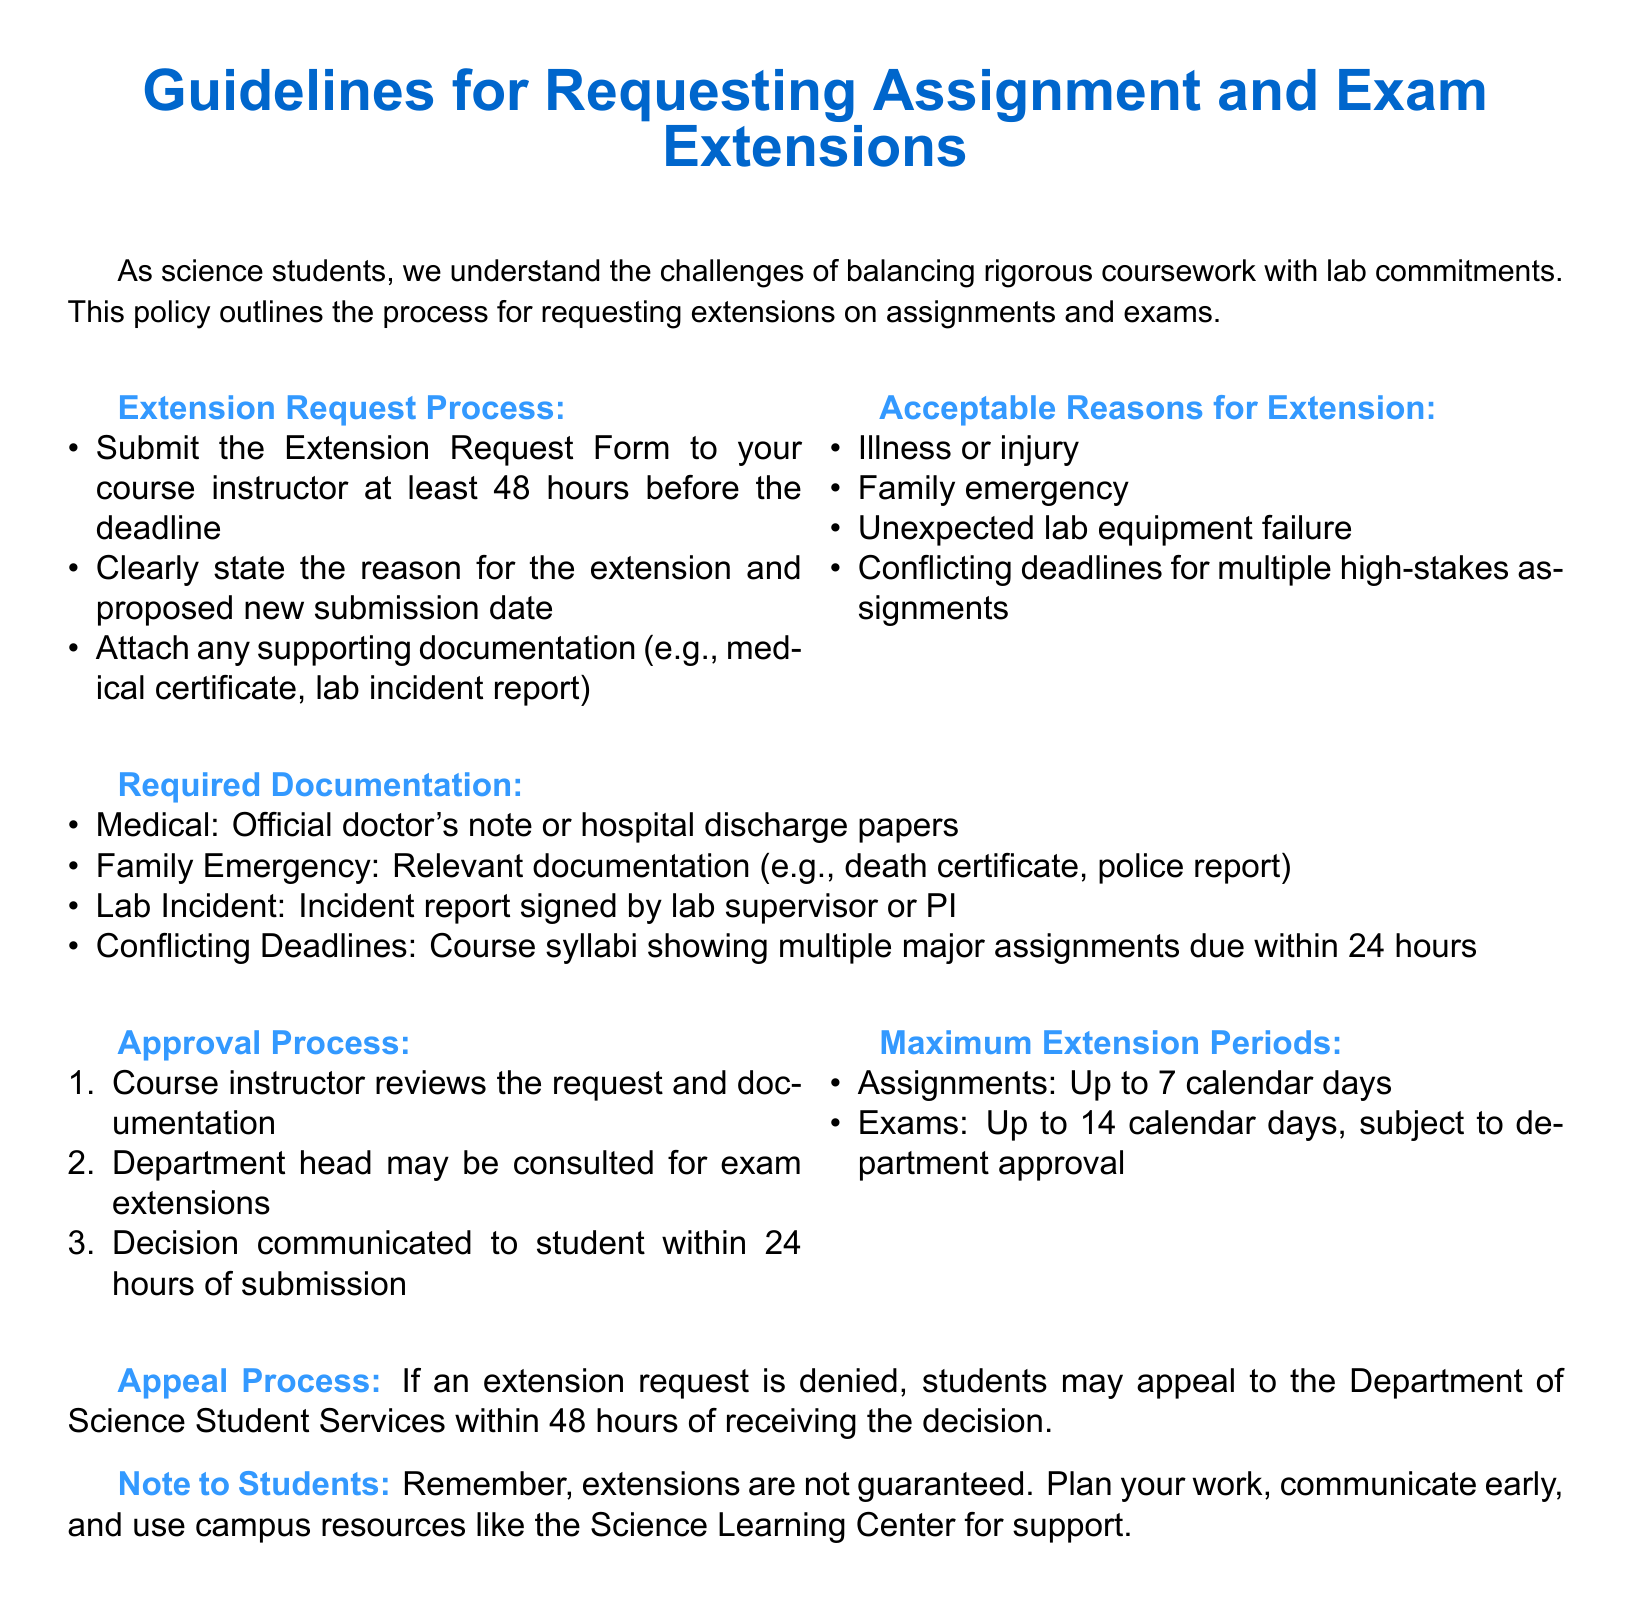What is the maximum extension period for assignments? The document states that the maximum extension period for assignments is seven calendar days.
Answer: 7 calendar days What is the required documentation for a medical condition? The document specifies that an official doctor's note or hospital discharge papers are required for medical conditions.
Answer: Official doctor's note How long before a deadline should you submit an extension request? According to the guidelines, you must submit the request at least 48 hours before the deadline.
Answer: 48 hours Who reviews the extension request? The course instructor is responsible for reviewing the extension request and documentation.
Answer: Course instructor What should you do if your extension request is denied? The document advises that if a request is denied, students may appeal to the Department of Science Student Services within 48 hours.
Answer: Appeal to the Department of Science Student Services What are acceptable reasons for requesting an extension? The guidelines list reasons such as illness or injury, family emergency, unexpected lab equipment failure, and conflicting deadlines.
Answer: Illness or injury, family emergency, unexpected lab equipment failure, conflicting deadlines What is the maximum extension period for exams? The document specifies that the maximum extension period for exams can be up to fourteen calendar days, subject to department approval.
Answer: 14 calendar days What type of report is needed for a lab incident? An incident report signed by the lab supervisor or principal investigator is required for a lab incident.
Answer: Incident report signed by lab supervisor or PI What is the role of the department head in the approval process? The department head may be consulted for exam extensions as part of the approval process.
Answer: Consulted for exam extensions 